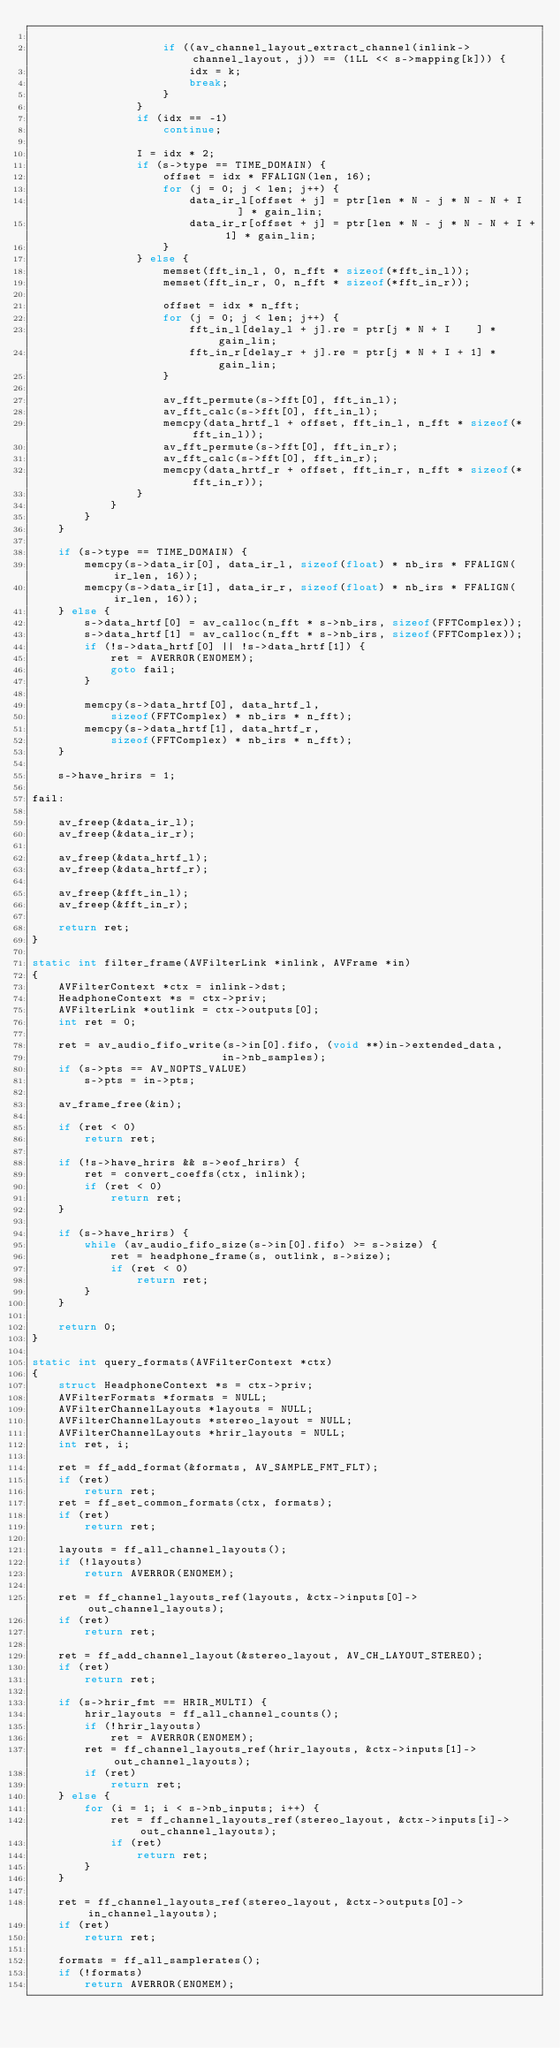Convert code to text. <code><loc_0><loc_0><loc_500><loc_500><_C_>
                    if ((av_channel_layout_extract_channel(inlink->channel_layout, j)) == (1LL << s->mapping[k])) {
                        idx = k;
                        break;
                    }
                }
                if (idx == -1)
                    continue;

                I = idx * 2;
                if (s->type == TIME_DOMAIN) {
                    offset = idx * FFALIGN(len, 16);
                    for (j = 0; j < len; j++) {
                        data_ir_l[offset + j] = ptr[len * N - j * N - N + I    ] * gain_lin;
                        data_ir_r[offset + j] = ptr[len * N - j * N - N + I + 1] * gain_lin;
                    }
                } else {
                    memset(fft_in_l, 0, n_fft * sizeof(*fft_in_l));
                    memset(fft_in_r, 0, n_fft * sizeof(*fft_in_r));

                    offset = idx * n_fft;
                    for (j = 0; j < len; j++) {
                        fft_in_l[delay_l + j].re = ptr[j * N + I    ] * gain_lin;
                        fft_in_r[delay_r + j].re = ptr[j * N + I + 1] * gain_lin;
                    }

                    av_fft_permute(s->fft[0], fft_in_l);
                    av_fft_calc(s->fft[0], fft_in_l);
                    memcpy(data_hrtf_l + offset, fft_in_l, n_fft * sizeof(*fft_in_l));
                    av_fft_permute(s->fft[0], fft_in_r);
                    av_fft_calc(s->fft[0], fft_in_r);
                    memcpy(data_hrtf_r + offset, fft_in_r, n_fft * sizeof(*fft_in_r));
                }
            }
        }
    }

    if (s->type == TIME_DOMAIN) {
        memcpy(s->data_ir[0], data_ir_l, sizeof(float) * nb_irs * FFALIGN(ir_len, 16));
        memcpy(s->data_ir[1], data_ir_r, sizeof(float) * nb_irs * FFALIGN(ir_len, 16));
    } else {
        s->data_hrtf[0] = av_calloc(n_fft * s->nb_irs, sizeof(FFTComplex));
        s->data_hrtf[1] = av_calloc(n_fft * s->nb_irs, sizeof(FFTComplex));
        if (!s->data_hrtf[0] || !s->data_hrtf[1]) {
            ret = AVERROR(ENOMEM);
            goto fail;
        }

        memcpy(s->data_hrtf[0], data_hrtf_l,
            sizeof(FFTComplex) * nb_irs * n_fft);
        memcpy(s->data_hrtf[1], data_hrtf_r,
            sizeof(FFTComplex) * nb_irs * n_fft);
    }

    s->have_hrirs = 1;

fail:

    av_freep(&data_ir_l);
    av_freep(&data_ir_r);

    av_freep(&data_hrtf_l);
    av_freep(&data_hrtf_r);

    av_freep(&fft_in_l);
    av_freep(&fft_in_r);

    return ret;
}

static int filter_frame(AVFilterLink *inlink, AVFrame *in)
{
    AVFilterContext *ctx = inlink->dst;
    HeadphoneContext *s = ctx->priv;
    AVFilterLink *outlink = ctx->outputs[0];
    int ret = 0;

    ret = av_audio_fifo_write(s->in[0].fifo, (void **)in->extended_data,
                             in->nb_samples);
    if (s->pts == AV_NOPTS_VALUE)
        s->pts = in->pts;

    av_frame_free(&in);

    if (ret < 0)
        return ret;

    if (!s->have_hrirs && s->eof_hrirs) {
        ret = convert_coeffs(ctx, inlink);
        if (ret < 0)
            return ret;
    }

    if (s->have_hrirs) {
        while (av_audio_fifo_size(s->in[0].fifo) >= s->size) {
            ret = headphone_frame(s, outlink, s->size);
            if (ret < 0)
                return ret;
        }
    }

    return 0;
}

static int query_formats(AVFilterContext *ctx)
{
    struct HeadphoneContext *s = ctx->priv;
    AVFilterFormats *formats = NULL;
    AVFilterChannelLayouts *layouts = NULL;
    AVFilterChannelLayouts *stereo_layout = NULL;
    AVFilterChannelLayouts *hrir_layouts = NULL;
    int ret, i;

    ret = ff_add_format(&formats, AV_SAMPLE_FMT_FLT);
    if (ret)
        return ret;
    ret = ff_set_common_formats(ctx, formats);
    if (ret)
        return ret;

    layouts = ff_all_channel_layouts();
    if (!layouts)
        return AVERROR(ENOMEM);

    ret = ff_channel_layouts_ref(layouts, &ctx->inputs[0]->out_channel_layouts);
    if (ret)
        return ret;

    ret = ff_add_channel_layout(&stereo_layout, AV_CH_LAYOUT_STEREO);
    if (ret)
        return ret;

    if (s->hrir_fmt == HRIR_MULTI) {
        hrir_layouts = ff_all_channel_counts();
        if (!hrir_layouts)
            ret = AVERROR(ENOMEM);
        ret = ff_channel_layouts_ref(hrir_layouts, &ctx->inputs[1]->out_channel_layouts);
        if (ret)
            return ret;
    } else {
        for (i = 1; i < s->nb_inputs; i++) {
            ret = ff_channel_layouts_ref(stereo_layout, &ctx->inputs[i]->out_channel_layouts);
            if (ret)
                return ret;
        }
    }

    ret = ff_channel_layouts_ref(stereo_layout, &ctx->outputs[0]->in_channel_layouts);
    if (ret)
        return ret;

    formats = ff_all_samplerates();
    if (!formats)
        return AVERROR(ENOMEM);</code> 